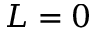<formula> <loc_0><loc_0><loc_500><loc_500>L = 0</formula> 